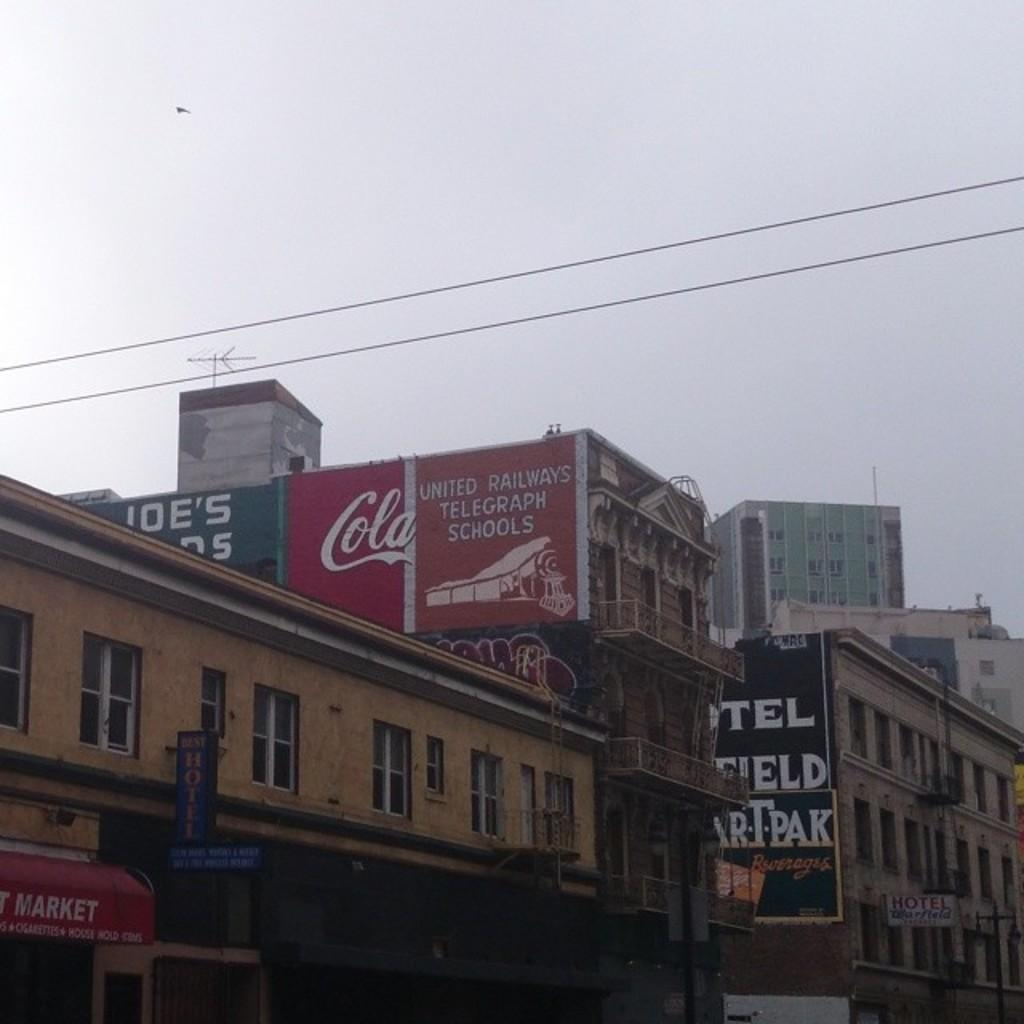<image>
Describe the image concisely. Buildings that have banners for cola and markets 